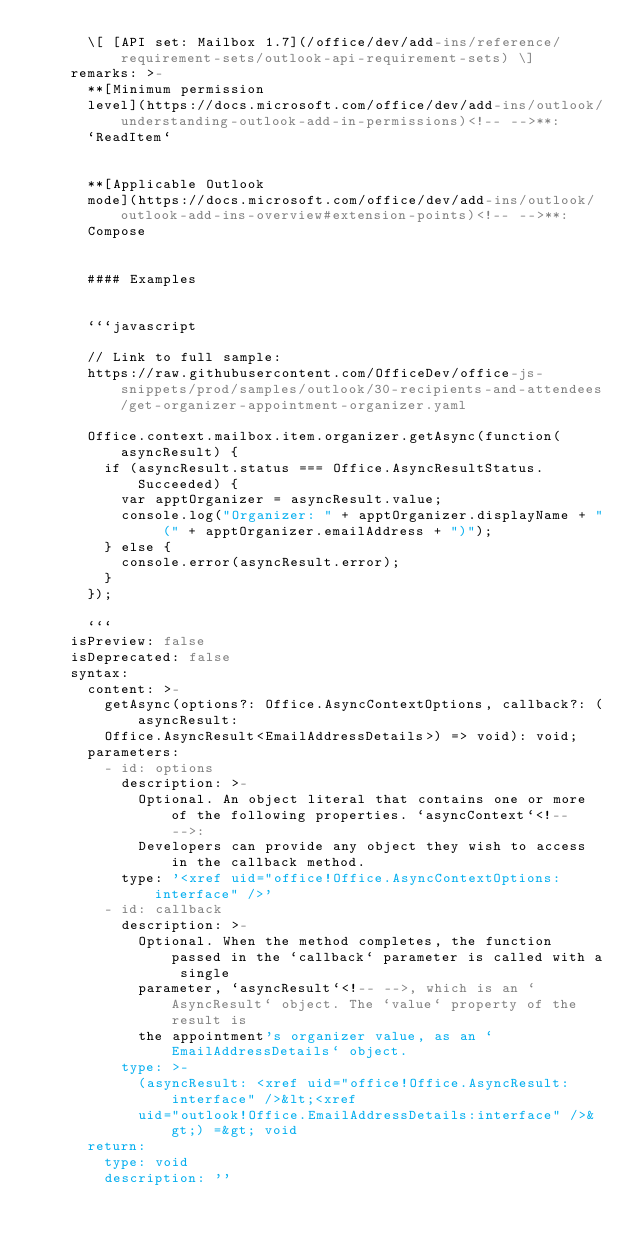Convert code to text. <code><loc_0><loc_0><loc_500><loc_500><_YAML_>      \[ [API set: Mailbox 1.7](/office/dev/add-ins/reference/requirement-sets/outlook-api-requirement-sets) \]
    remarks: >-
      **[Minimum permission
      level](https://docs.microsoft.com/office/dev/add-ins/outlook/understanding-outlook-add-in-permissions)<!-- -->**:
      `ReadItem`


      **[Applicable Outlook
      mode](https://docs.microsoft.com/office/dev/add-ins/outlook/outlook-add-ins-overview#extension-points)<!-- -->**:
      Compose


      #### Examples


      ```javascript

      // Link to full sample:
      https://raw.githubusercontent.com/OfficeDev/office-js-snippets/prod/samples/outlook/30-recipients-and-attendees/get-organizer-appointment-organizer.yaml

      Office.context.mailbox.item.organizer.getAsync(function(asyncResult) {
        if (asyncResult.status === Office.AsyncResultStatus.Succeeded) {
          var apptOrganizer = asyncResult.value;
          console.log("Organizer: " + apptOrganizer.displayName + " (" + apptOrganizer.emailAddress + ")");
        } else {
          console.error(asyncResult.error);
        }
      });

      ```
    isPreview: false
    isDeprecated: false
    syntax:
      content: >-
        getAsync(options?: Office.AsyncContextOptions, callback?: (asyncResult:
        Office.AsyncResult<EmailAddressDetails>) => void): void;
      parameters:
        - id: options
          description: >-
            Optional. An object literal that contains one or more of the following properties. `asyncContext`<!-- -->:
            Developers can provide any object they wish to access in the callback method.
          type: '<xref uid="office!Office.AsyncContextOptions:interface" />'
        - id: callback
          description: >-
            Optional. When the method completes, the function passed in the `callback` parameter is called with a single
            parameter, `asyncResult`<!-- -->, which is an `AsyncResult` object. The `value` property of the result is
            the appointment's organizer value, as an `EmailAddressDetails` object.
          type: >-
            (asyncResult: <xref uid="office!Office.AsyncResult:interface" />&lt;<xref
            uid="outlook!Office.EmailAddressDetails:interface" />&gt;) =&gt; void
      return:
        type: void
        description: ''
</code> 